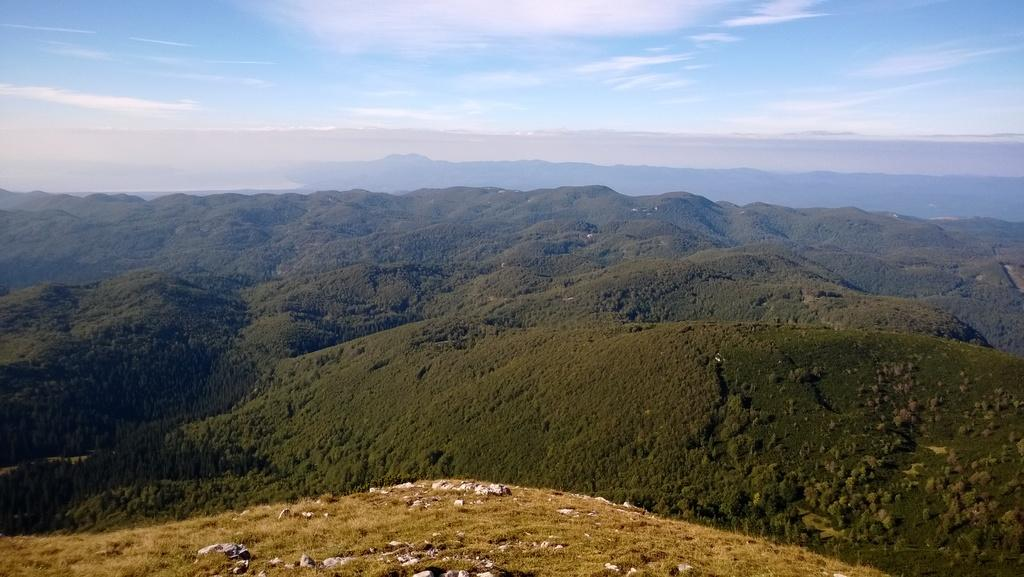What type of landscape feature is visible in the front of the image? There are hills in the front of the image. What can be seen in the background of the image? There are clouds and the sky visible in the background of the image. Are there any signs of a pest infestation in the image? There is no indication of a pest infestation in the image, as it primarily features hills, clouds, and the sky. 